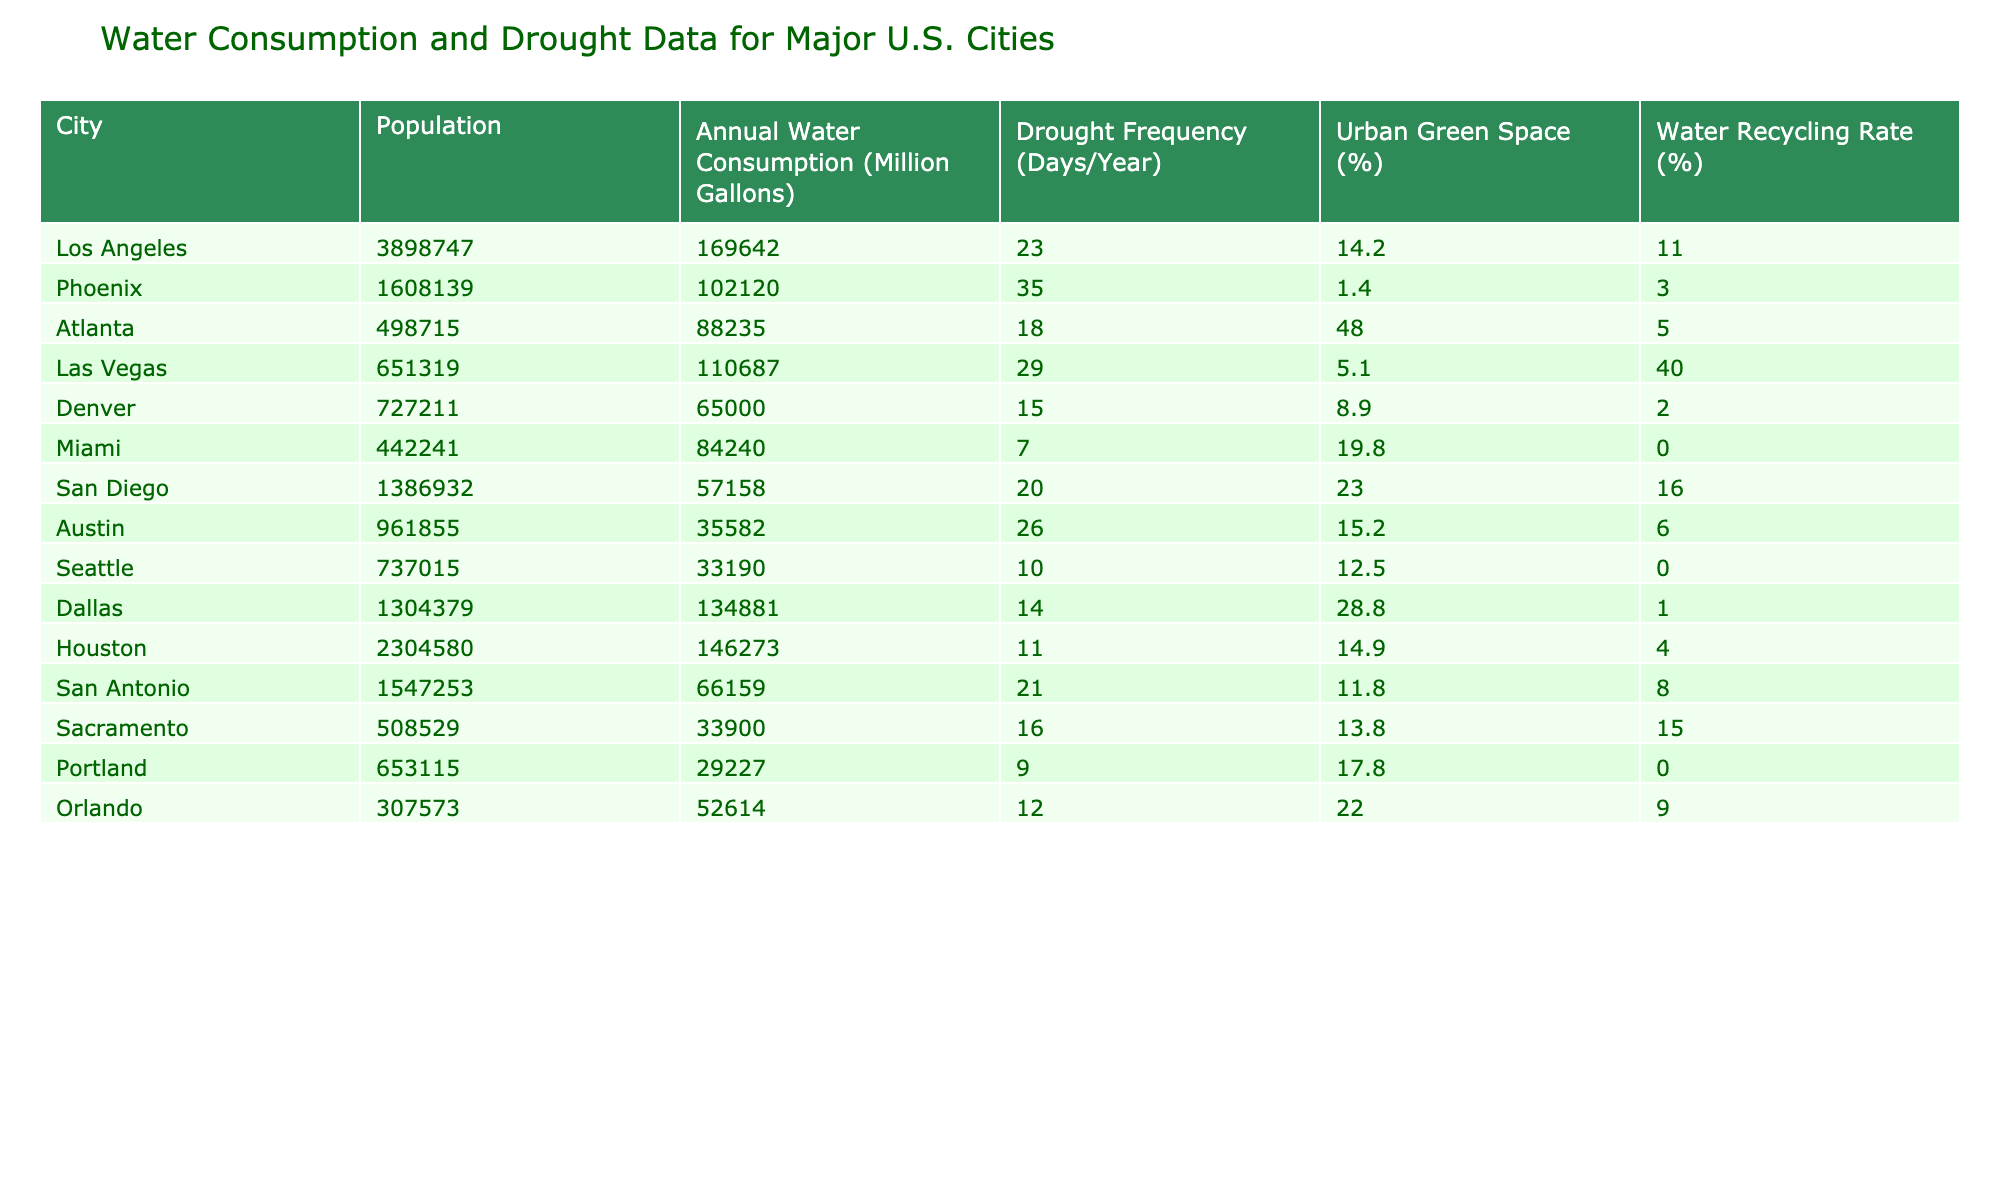What is the annual water consumption of Los Angeles? The table lists the annual water consumption for Los Angeles as 169,642 million gallons.
Answer: 169,642 million gallons Which city has the highest drought frequency per year? Reviewing the table, Phoenix has the highest drought frequency listed at 35 days per year.
Answer: Phoenix What is the average urban green space percentage for the cities in the table? Calculate the total urban green space percentage by summing (14.2 + 1.4 + 48.0 + 5.1 + 8.9 + 19.8 + 23.0 + 15.2 + 12.5 + 28.8 + 14.9 + 11.8 + 13.8 + 17.8 + 22.0) = 319.3. There are 15 cities, so the average is 319.3 / 15 = 21.29.
Answer: 21.29% Is there a correlation between population size and water consumption in the cities listed? While the table allows for visual comparison, a specific correlation calculation is necessary. Los Angeles has a high population and high water consumption, while Seattle has lower values for both. Though preliminary observations suggest cities with larger populations tend to consume more water, a definitive conclusion can't be reached without deeper statistical analysis.
Answer: Not definitive Which city has the lowest water recycling rate? Miami has a 0% water recycling rate, which is the lowest listed in the table.
Answer: Miami What is the difference in drought frequency between Phoenix and San Diego? Phoenix has a drought frequency of 35 days, and San Diego has 20 days. The difference is 35 - 20 = 15 days.
Answer: 15 days How does the urban green space percentage relate to water recycling rates in Dallas and Houston? Dallas has 28.8% urban green space and a 1% water recycling rate, while Houston has 14.9% and a 4% recycling rate. Despite having higher urban green space, Dallas has a lower recycling rate than Houston. This indicates that more green space doesn't necessarily lead to higher recycling rates.
Answer: Not directly related Which city consumes more water: San Antonio or Denver? According to the table, San Antonio consumes 66,159 million gallons and Denver consumes 65,000 million gallons. Thus, San Antonio consumes more water by 1,159 million gallons.
Answer: San Antonio Is the drought frequency in Las Vegas higher than in Atlanta? Las Vegas has a drought frequency of 29 days, while Atlanta has 18 days, meaning Las Vegas does have a higher frequency of drought days.
Answer: Yes What is the total annual water consumption of the three largest metropolitan areas (Los Angeles, Houston, and Phoenix)? The total water consumption is calculated as: 169,642 (Los Angeles) + 146,273 (Houston) + 102,120 (Phoenix) = 418,035 million gallons.
Answer: 418,035 million gallons Which city has the most urban green space relative to its population size? Comparing the urban green space percentages, Atlanta has 48%, which is high relative to its population size of 498,715, suggesting it maximizes green space despite urbanization.
Answer: Atlanta 